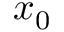<formula> <loc_0><loc_0><loc_500><loc_500>x _ { 0 }</formula> 